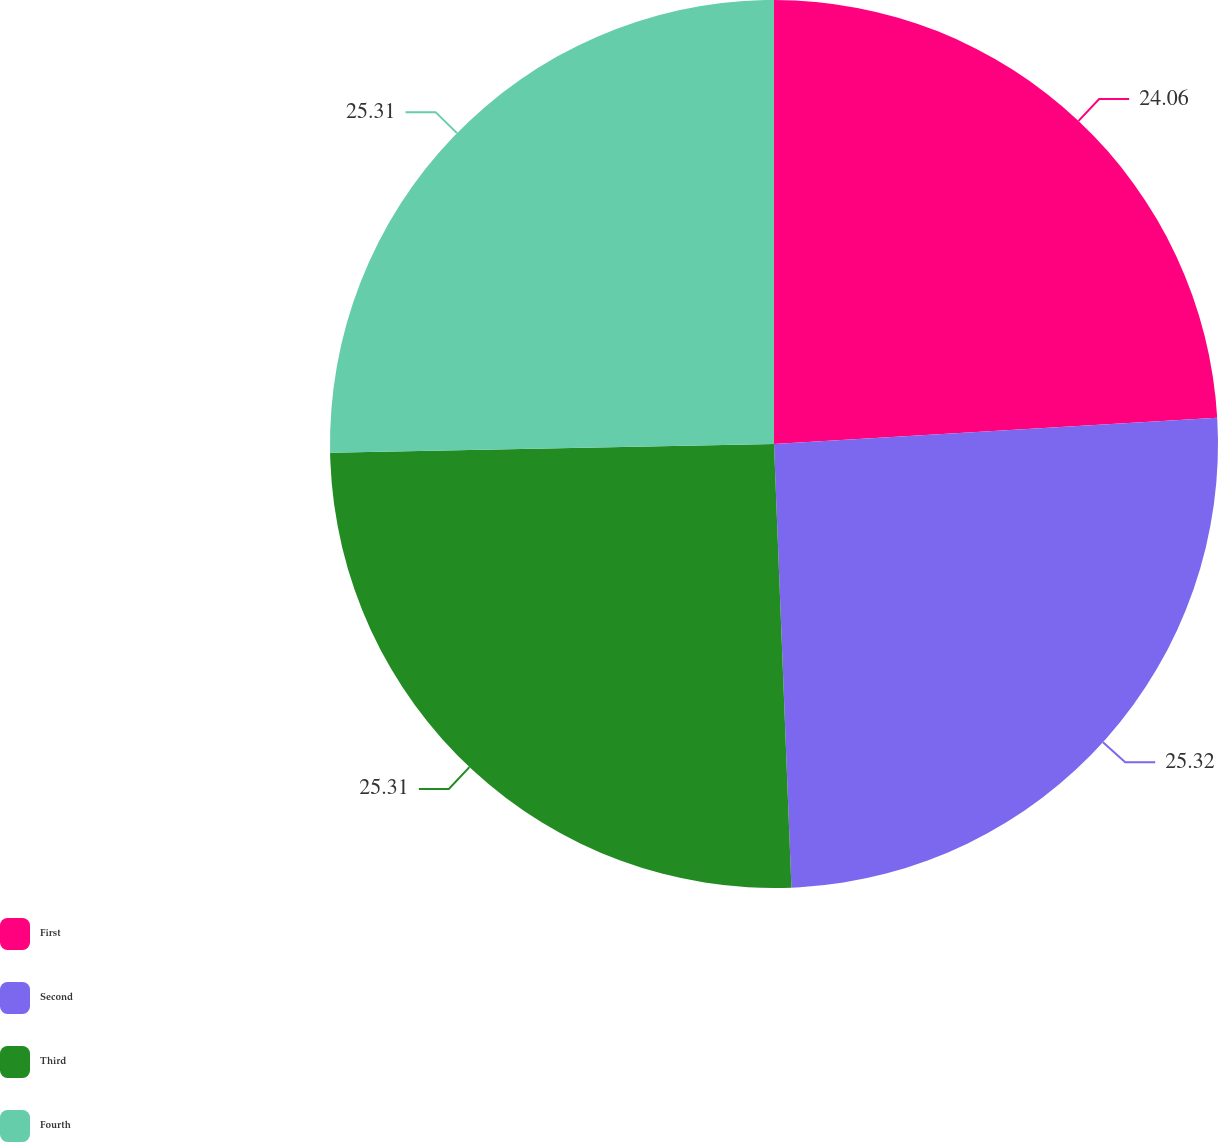Convert chart. <chart><loc_0><loc_0><loc_500><loc_500><pie_chart><fcel>First<fcel>Second<fcel>Third<fcel>Fourth<nl><fcel>24.06%<fcel>25.31%<fcel>25.31%<fcel>25.31%<nl></chart> 